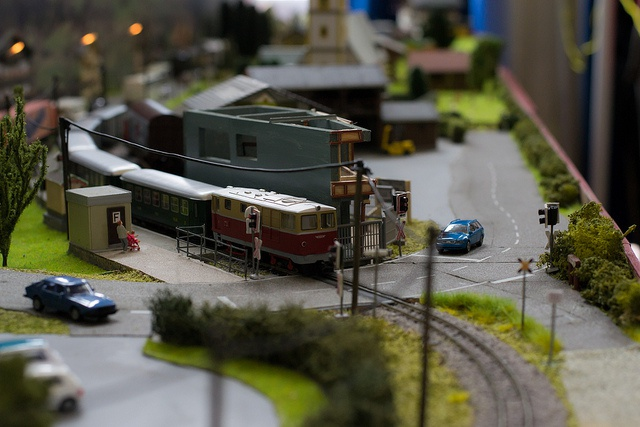Describe the objects in this image and their specific colors. I can see train in black, lightgray, darkgray, and gray tones, car in black, gray, and lightgray tones, car in black, darkgray, gray, and lightgray tones, car in black, gray, blue, and darkblue tones, and traffic light in black, gray, and darkgray tones in this image. 